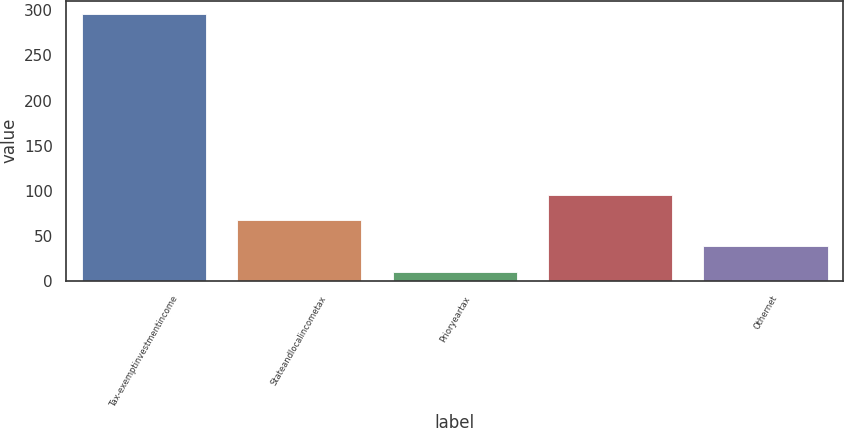<chart> <loc_0><loc_0><loc_500><loc_500><bar_chart><fcel>Tax-exemptinvestmentincome<fcel>Stateandlocalincometax<fcel>Prioryeartax<fcel>Unnamed: 3<fcel>Othernet<nl><fcel>296<fcel>67.2<fcel>10<fcel>95.8<fcel>38.6<nl></chart> 